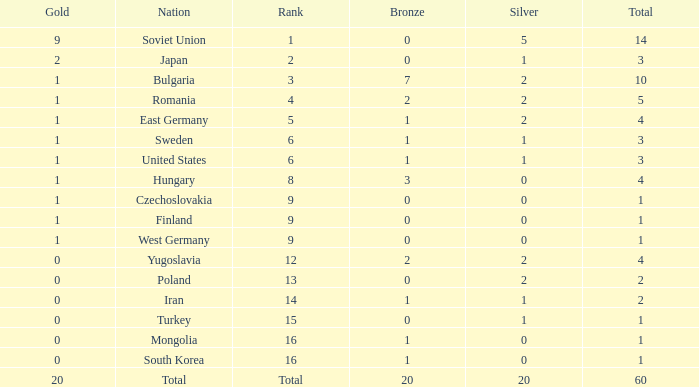What is the sum of bronzes having silvers over 5 and golds under 20? None. 